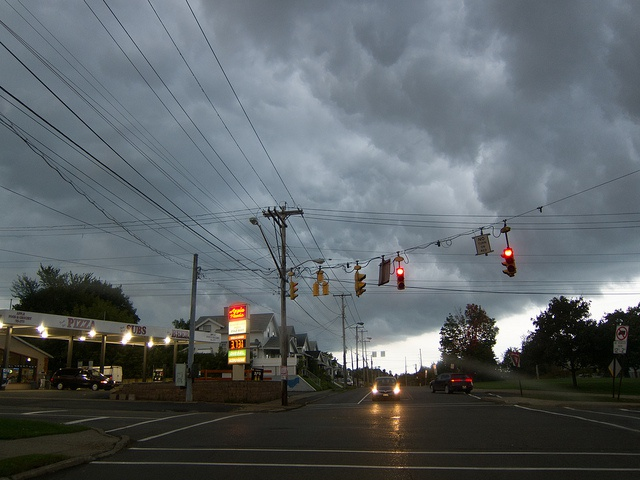Describe the objects in this image and their specific colors. I can see truck in gray, black, olive, and maroon tones, car in gray, black, maroon, red, and darkgreen tones, car in gray, black, and maroon tones, traffic light in gray, black, maroon, and brown tones, and traffic light in gray, maroon, and black tones in this image. 